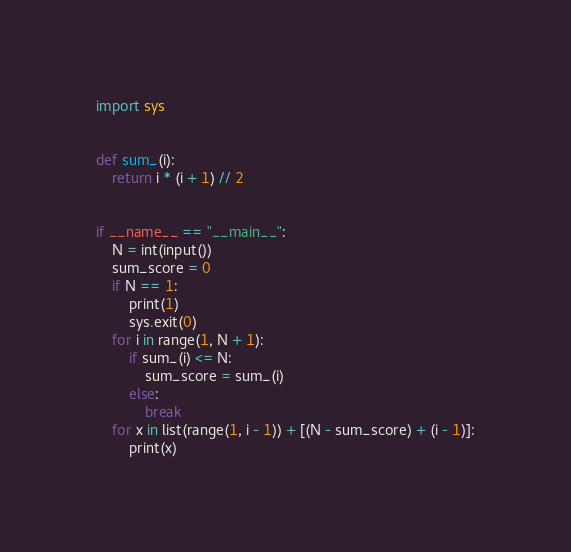<code> <loc_0><loc_0><loc_500><loc_500><_Python_>import sys


def sum_(i):
    return i * (i + 1) // 2


if __name__ == "__main__":
    N = int(input())
    sum_score = 0
    if N == 1:
        print(1)
        sys.exit(0)
    for i in range(1, N + 1):
        if sum_(i) <= N:
            sum_score = sum_(i)
        else:
            break
    for x in list(range(1, i - 1)) + [(N - sum_score) + (i - 1)]:
        print(x)

</code> 